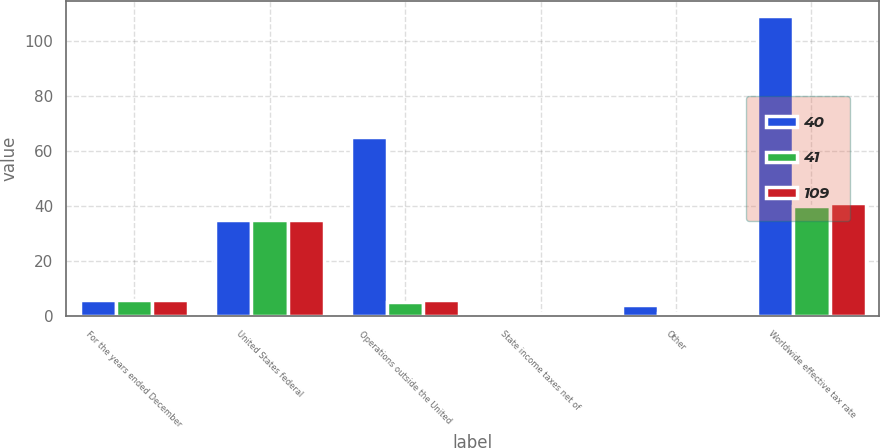<chart> <loc_0><loc_0><loc_500><loc_500><stacked_bar_chart><ecel><fcel>For the years ended December<fcel>United States federal<fcel>Operations outside the United<fcel>State income taxes net of<fcel>Other<fcel>Worldwide effective tax rate<nl><fcel>40<fcel>6<fcel>35<fcel>65<fcel>1<fcel>4<fcel>109<nl><fcel>41<fcel>6<fcel>35<fcel>5<fcel>1<fcel>1<fcel>40<nl><fcel>109<fcel>6<fcel>35<fcel>6<fcel>1<fcel>1<fcel>41<nl></chart> 